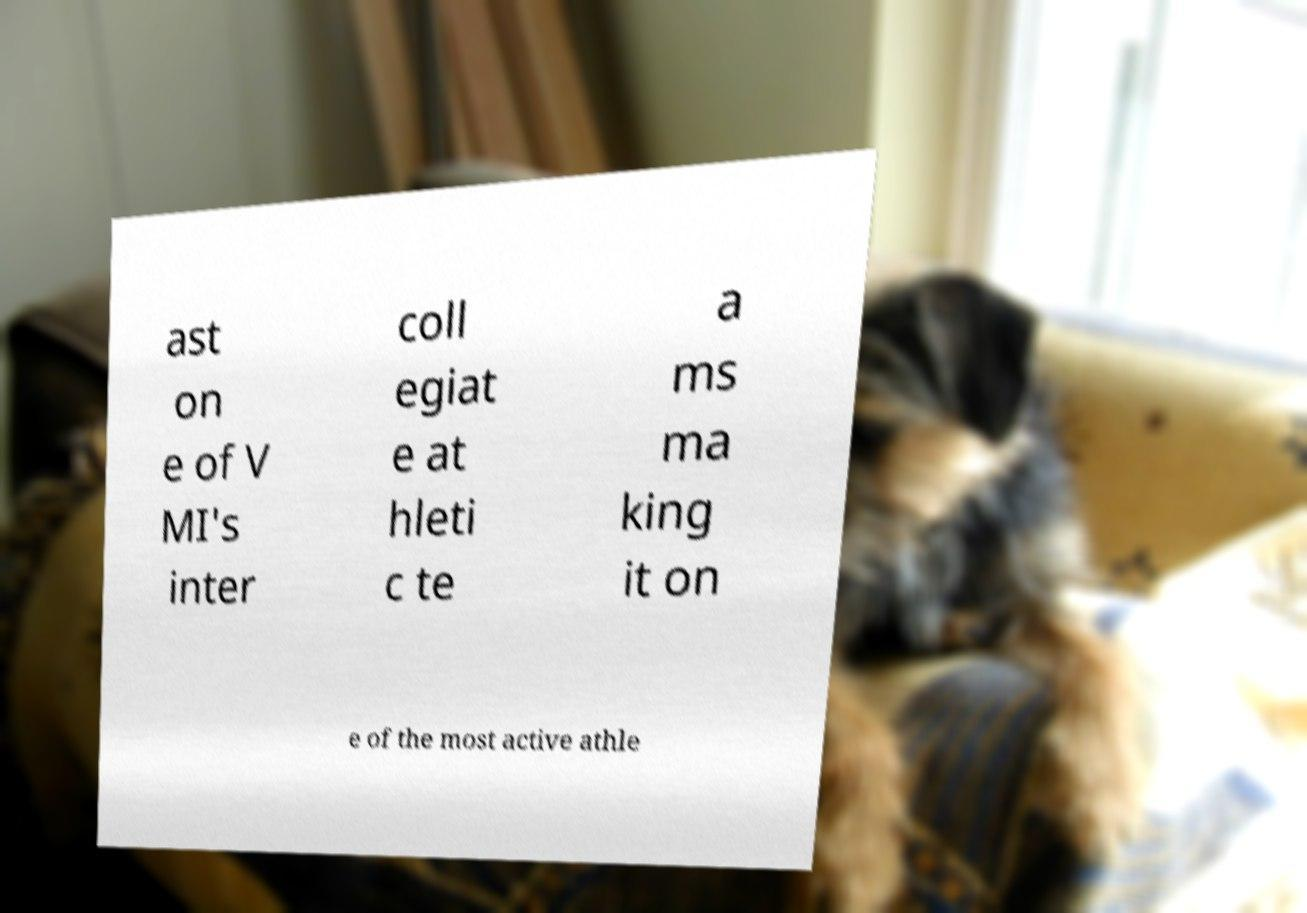Could you extract and type out the text from this image? ast on e of V MI's inter coll egiat e at hleti c te a ms ma king it on e of the most active athle 